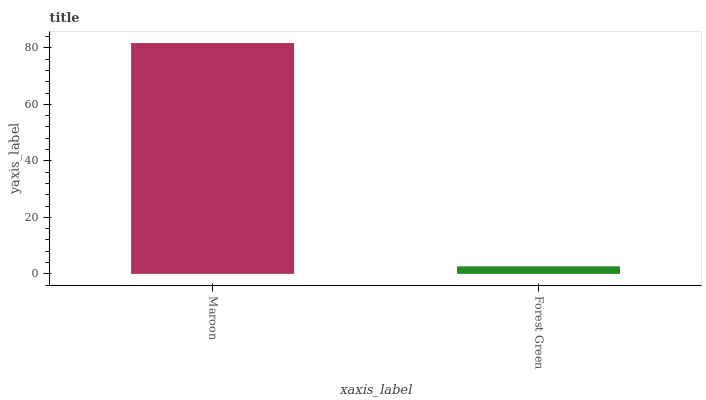Is Forest Green the minimum?
Answer yes or no. Yes. Is Maroon the maximum?
Answer yes or no. Yes. Is Forest Green the maximum?
Answer yes or no. No. Is Maroon greater than Forest Green?
Answer yes or no. Yes. Is Forest Green less than Maroon?
Answer yes or no. Yes. Is Forest Green greater than Maroon?
Answer yes or no. No. Is Maroon less than Forest Green?
Answer yes or no. No. Is Maroon the high median?
Answer yes or no. Yes. Is Forest Green the low median?
Answer yes or no. Yes. Is Forest Green the high median?
Answer yes or no. No. Is Maroon the low median?
Answer yes or no. No. 